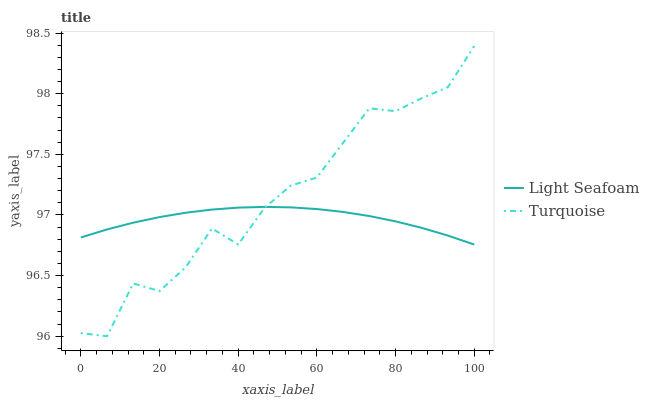Does Light Seafoam have the minimum area under the curve?
Answer yes or no. Yes. Does Turquoise have the maximum area under the curve?
Answer yes or no. Yes. Does Light Seafoam have the maximum area under the curve?
Answer yes or no. No. Is Light Seafoam the smoothest?
Answer yes or no. Yes. Is Turquoise the roughest?
Answer yes or no. Yes. Is Light Seafoam the roughest?
Answer yes or no. No. Does Light Seafoam have the lowest value?
Answer yes or no. No. Does Turquoise have the highest value?
Answer yes or no. Yes. Does Light Seafoam have the highest value?
Answer yes or no. No. Does Light Seafoam intersect Turquoise?
Answer yes or no. Yes. Is Light Seafoam less than Turquoise?
Answer yes or no. No. Is Light Seafoam greater than Turquoise?
Answer yes or no. No. 